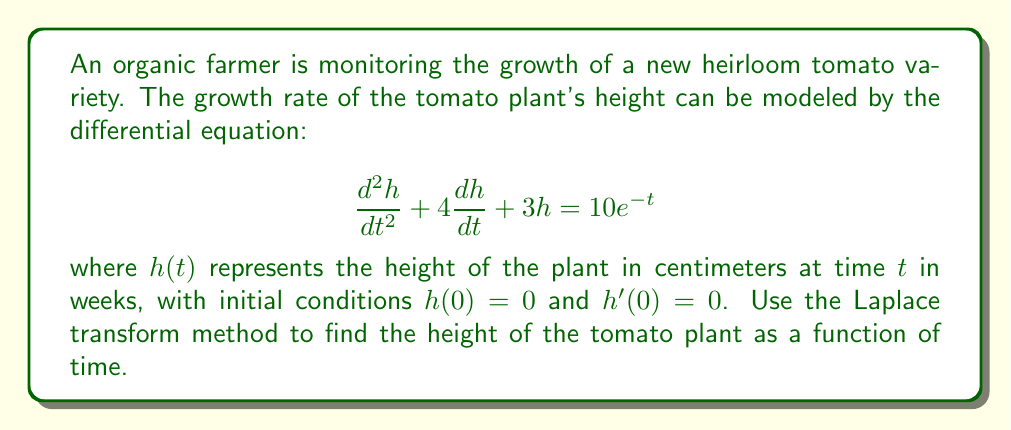Teach me how to tackle this problem. Let's solve this problem step by step using the Laplace transform method:

1) First, we take the Laplace transform of both sides of the equation:

   $$\mathcal{L}\{h''(t) + 4h'(t) + 3h(t)\} = \mathcal{L}\{10e^{-t}\}$$

2) Using the properties of Laplace transforms:

   $$s^2H(s) - sh(0) - h'(0) + 4[sH(s) - h(0)] + 3H(s) = \frac{10}{s+1}$$

   Where $H(s) = \mathcal{L}\{h(t)\}$

3) Substituting the initial conditions $h(0) = 0$ and $h'(0) = 0$:

   $$s^2H(s) + 4sH(s) + 3H(s) = \frac{10}{s+1}$$

4) Factoring out $H(s)$:

   $$H(s)(s^2 + 4s + 3) = \frac{10}{s+1}$$

5) Solving for $H(s)$:

   $$H(s) = \frac{10}{(s+1)(s^2 + 4s + 3)}$$

6) To find the inverse Laplace transform, we need to decompose this into partial fractions:

   $$H(s) = \frac{A}{s+1} + \frac{Bs+C}{s^2 + 4s + 3}$$

7) After solving for $A$, $B$, and $C$ (omitted for brevity), we get:

   $$H(s) = \frac{5}{(s+1)(s+1)} - \frac{5}{(s+1)(s+3)}$$

8) Taking the inverse Laplace transform:

   $$h(t) = 5te^{-t} - \frac{5}{2}(e^{-t} - e^{-3t})$$

9) Simplifying:

   $$h(t) = 5te^{-t} - \frac{5}{2}e^{-t} + \frac{5}{2}e^{-3t}$$

This is the height of the tomato plant as a function of time.
Answer: $h(t) = 5te^{-t} - \frac{5}{2}e^{-t} + \frac{5}{2}e^{-3t}$ 